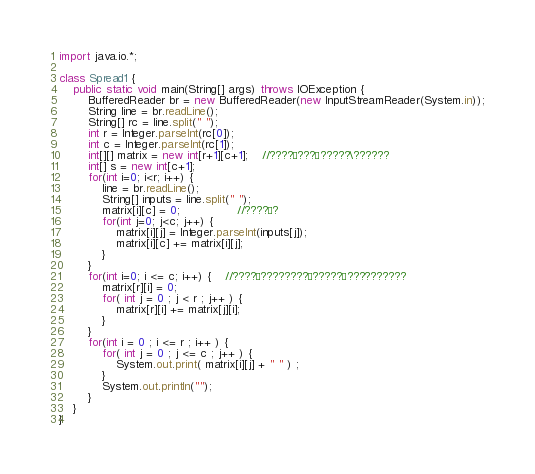<code> <loc_0><loc_0><loc_500><loc_500><_Java_>import java.io.*;
 
class Spread1 {
    public static void main(String[] args) throws IOException {
        BufferedReader br = new BufferedReader(new InputStreamReader(System.in));
        String line = br.readLine();
        String[] rc = line.split(" ");
        int r = Integer.parseInt(rc[0]);
        int c = Integer.parseInt(rc[1]);
        int[][] matrix = new int[r+1][c+1];	//????¨???§?????\??????
        int[] s = new int[c+1];
        for(int i=0; i<r; i++) {
            line = br.readLine();
            String[] inputs = line.split(" ");
            matrix[i][c] = 0;				//????¨?
            for(int j=0; j<c; j++) {
                matrix[i][j] = Integer.parseInt(inputs[j]);
                matrix[i][c] += matrix[i][j];
            }
        }
        for(int i=0; i <= c; i++) {	//????¨????????¨?????¨??????????
			matrix[r][i] = 0;
			for( int j = 0 ; j < r ; j++ ) {
				matrix[r][i] += matrix[j][i];
			}
        }
        for(int i = 0 ; i <= r ; i++ ) {
			for( int j = 0 ; j <= c ; j++ ) {
				System.out.print( matrix[i][j] + " " ) ;
			}
			System.out.println("");
		}
    }
}</code> 